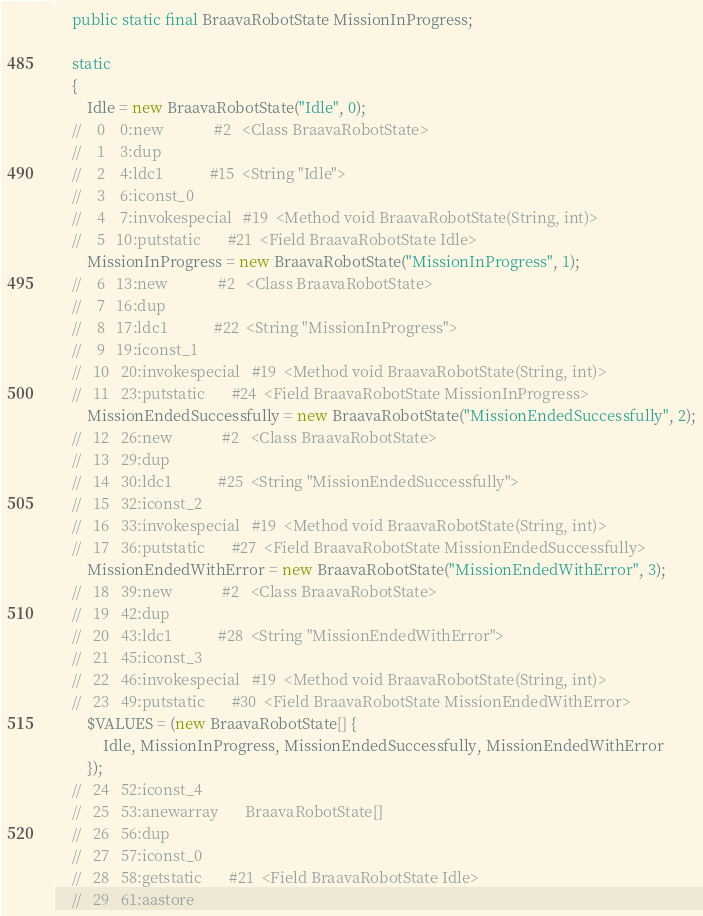<code> <loc_0><loc_0><loc_500><loc_500><_Java_>	public static final BraavaRobotState MissionInProgress;

	static 
	{
		Idle = new BraavaRobotState("Idle", 0);
	//    0    0:new             #2   <Class BraavaRobotState>
	//    1    3:dup             
	//    2    4:ldc1            #15  <String "Idle">
	//    3    6:iconst_0        
	//    4    7:invokespecial   #19  <Method void BraavaRobotState(String, int)>
	//    5   10:putstatic       #21  <Field BraavaRobotState Idle>
		MissionInProgress = new BraavaRobotState("MissionInProgress", 1);
	//    6   13:new             #2   <Class BraavaRobotState>
	//    7   16:dup             
	//    8   17:ldc1            #22  <String "MissionInProgress">
	//    9   19:iconst_1        
	//   10   20:invokespecial   #19  <Method void BraavaRobotState(String, int)>
	//   11   23:putstatic       #24  <Field BraavaRobotState MissionInProgress>
		MissionEndedSuccessfully = new BraavaRobotState("MissionEndedSuccessfully", 2);
	//   12   26:new             #2   <Class BraavaRobotState>
	//   13   29:dup             
	//   14   30:ldc1            #25  <String "MissionEndedSuccessfully">
	//   15   32:iconst_2        
	//   16   33:invokespecial   #19  <Method void BraavaRobotState(String, int)>
	//   17   36:putstatic       #27  <Field BraavaRobotState MissionEndedSuccessfully>
		MissionEndedWithError = new BraavaRobotState("MissionEndedWithError", 3);
	//   18   39:new             #2   <Class BraavaRobotState>
	//   19   42:dup             
	//   20   43:ldc1            #28  <String "MissionEndedWithError">
	//   21   45:iconst_3        
	//   22   46:invokespecial   #19  <Method void BraavaRobotState(String, int)>
	//   23   49:putstatic       #30  <Field BraavaRobotState MissionEndedWithError>
		$VALUES = (new BraavaRobotState[] {
			Idle, MissionInProgress, MissionEndedSuccessfully, MissionEndedWithError
		});
	//   24   52:iconst_4        
	//   25   53:anewarray       BraavaRobotState[]
	//   26   56:dup             
	//   27   57:iconst_0        
	//   28   58:getstatic       #21  <Field BraavaRobotState Idle>
	//   29   61:aastore         </code> 